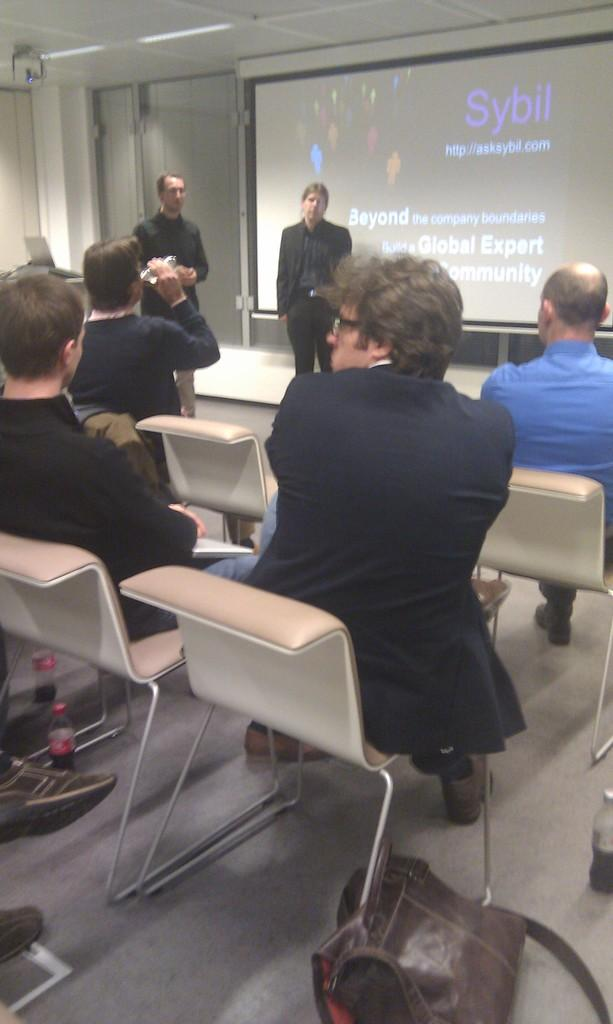How many people are standing in the image? There are two persons standing in the image. What is happening behind the standing persons? There is a projected image behind the two standing persons. What is the position of the group of people in relation to the standing persons? The group of people is sitting in front of the standing persons. How many rabbits are hopping on the moon in the image? There are no rabbits or moons present in the image. 